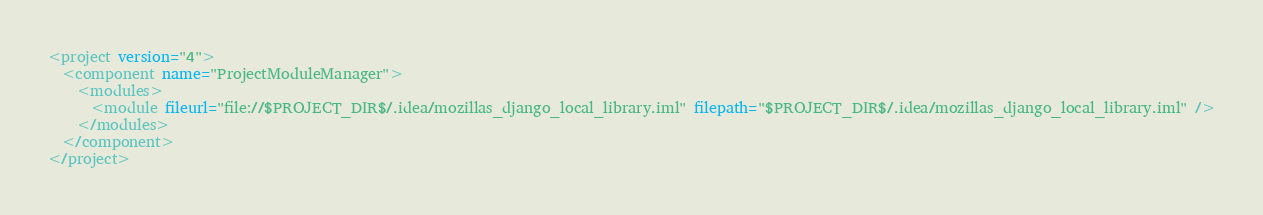<code> <loc_0><loc_0><loc_500><loc_500><_XML_><project version="4">
  <component name="ProjectModuleManager">
    <modules>
      <module fileurl="file://$PROJECT_DIR$/.idea/mozillas_django_local_library.iml" filepath="$PROJECT_DIR$/.idea/mozillas_django_local_library.iml" />
    </modules>
  </component>
</project></code> 